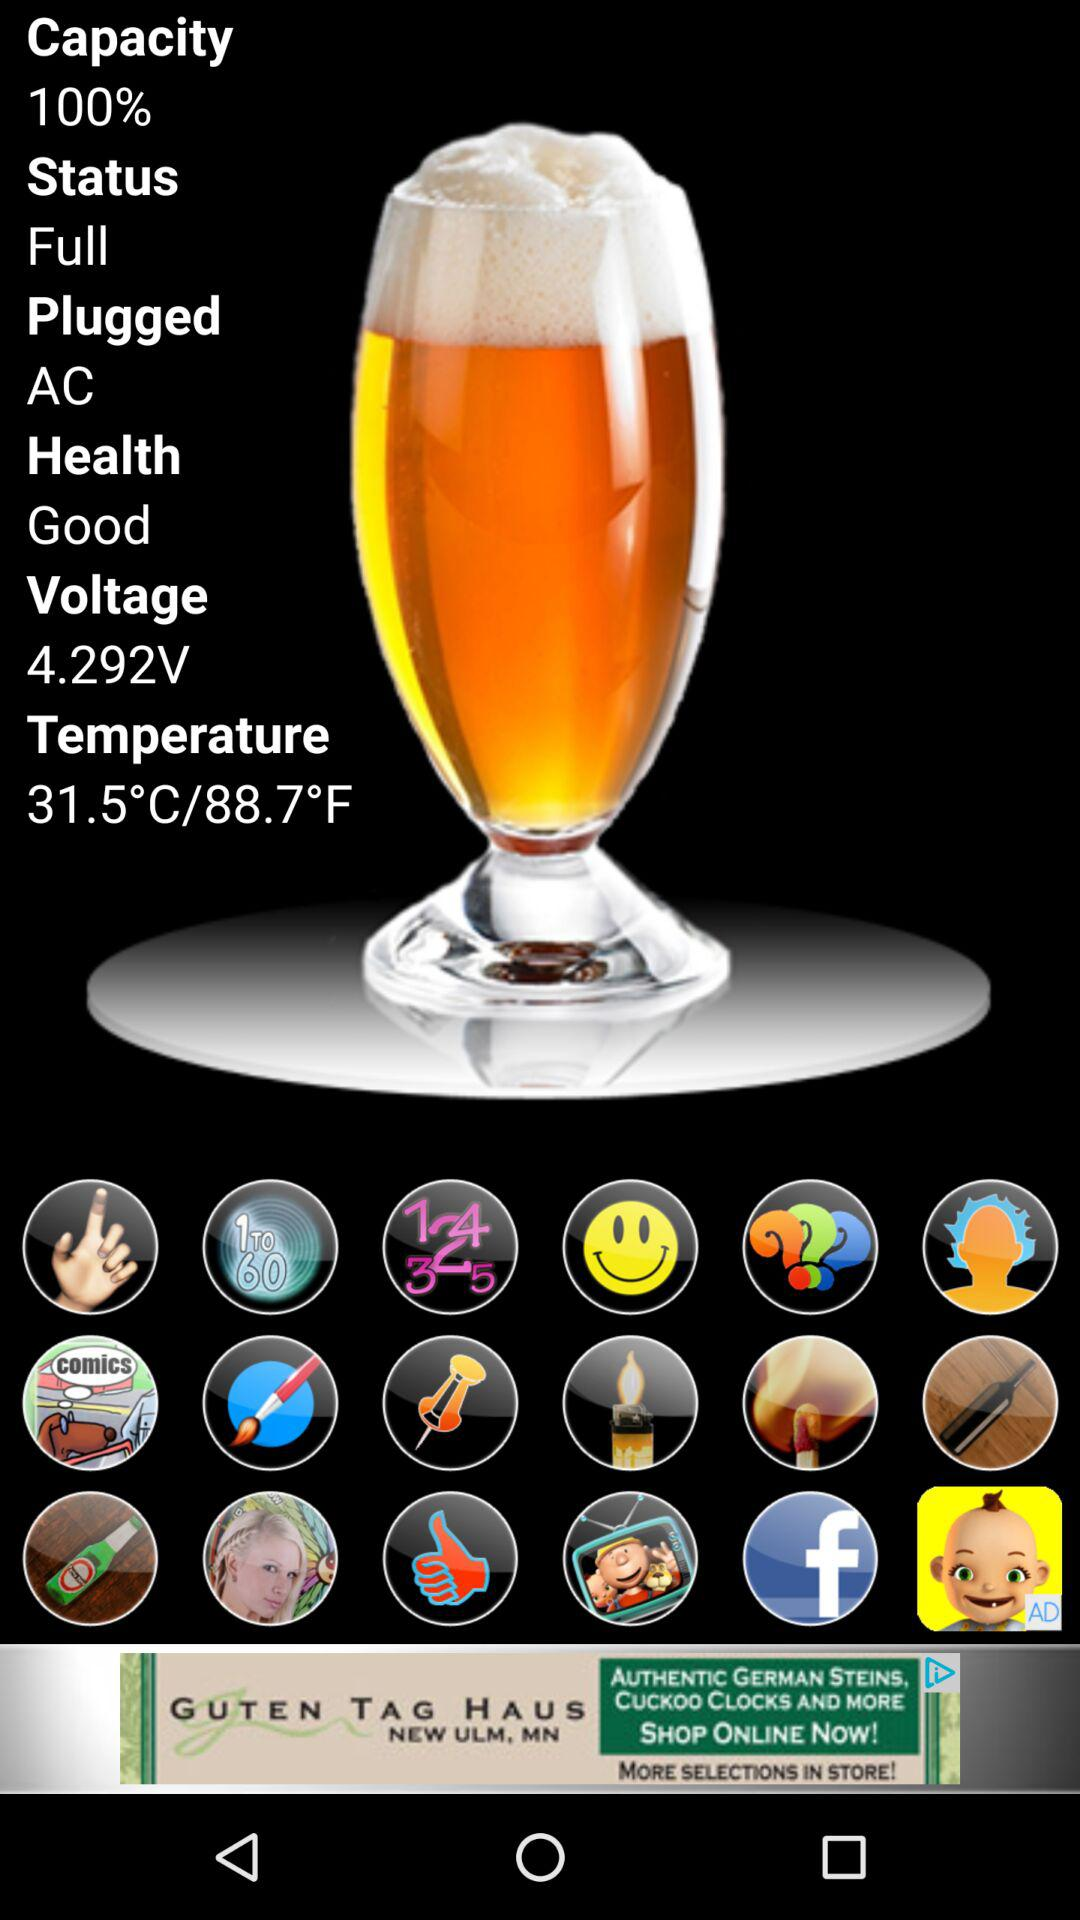Which type of supply is plugged in? The type of supply that is plugged in is AC. 